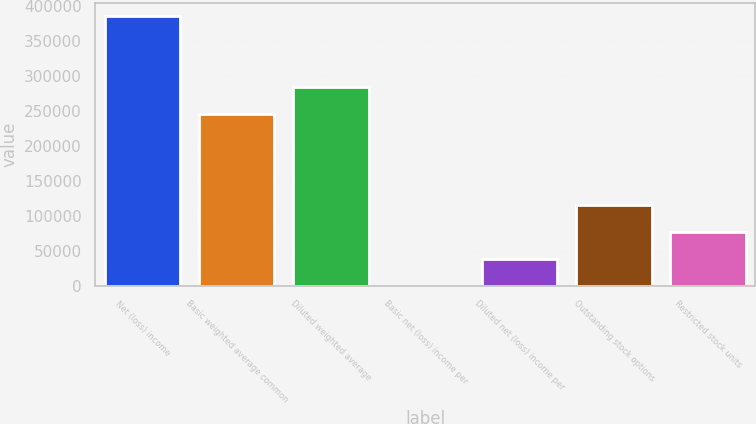Convert chart. <chart><loc_0><loc_0><loc_500><loc_500><bar_chart><fcel>Net (loss) income<fcel>Basic weighted average common<fcel>Diluted weighted average<fcel>Basic net (loss) income per<fcel>Diluted net (loss) income per<fcel>Outstanding stock options<fcel>Restricted stock units<nl><fcel>385617<fcel>245968<fcel>284530<fcel>1.57<fcel>38563.1<fcel>115686<fcel>77124.6<nl></chart> 